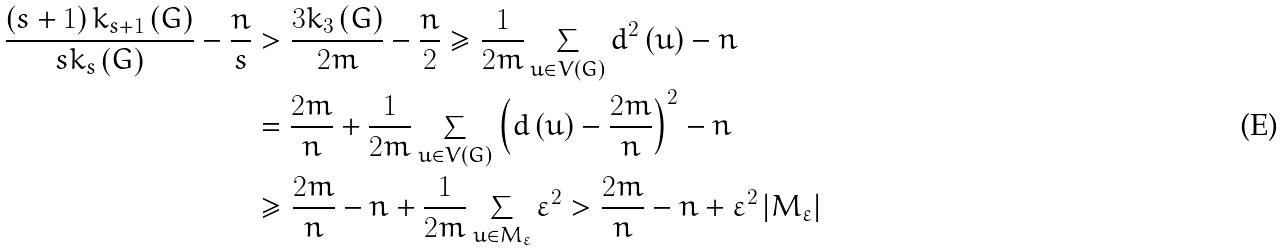Convert formula to latex. <formula><loc_0><loc_0><loc_500><loc_500>\frac { \left ( s + 1 \right ) k _ { s + 1 } \left ( G \right ) } { s k _ { s } \left ( G \right ) } - \frac { n } { s } & > \frac { 3 k _ { 3 } \left ( G \right ) } { 2 m } - \frac { n } { 2 } \geq \frac { 1 } { 2 m } \sum _ { u \in V \left ( G \right ) } d ^ { 2 } \left ( u \right ) - n \\ & = \frac { 2 m } { n } + \frac { 1 } { 2 m } \sum _ { u \in V \left ( G \right ) } \left ( d \left ( u \right ) - \frac { 2 m } { n } \right ) ^ { 2 } - n \\ & \geq \frac { 2 m } { n } - n + \frac { 1 } { 2 m } \sum _ { u \in M _ { \varepsilon } } \varepsilon ^ { 2 } > \frac { 2 m } { n } - n + \varepsilon ^ { 2 } \left | M _ { \varepsilon } \right |</formula> 